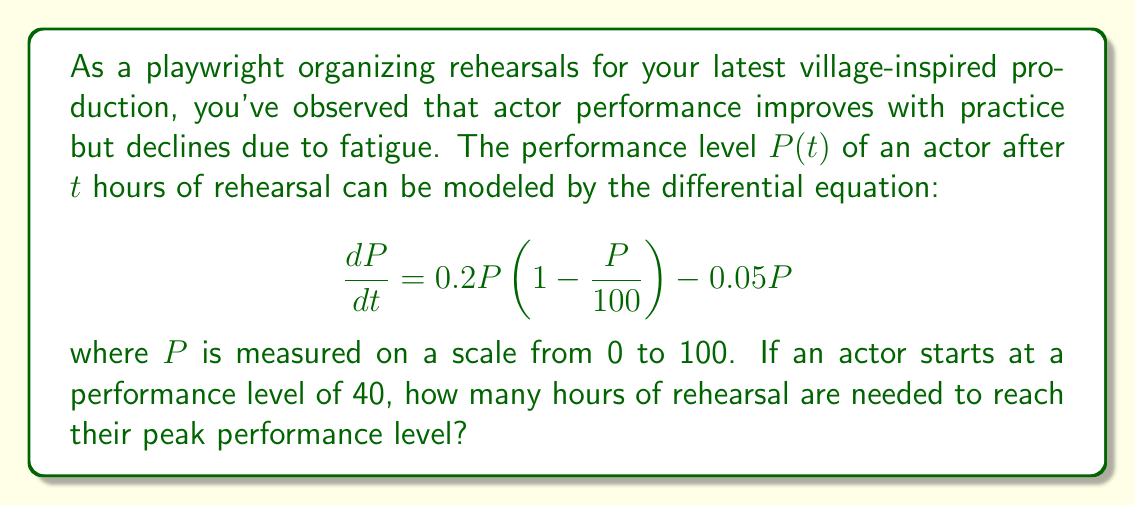Can you solve this math problem? To solve this problem, we need to follow these steps:

1) First, we need to find the equilibrium points of the differential equation. At equilibrium, $\frac{dP}{dt} = 0$. So:

   $$0 = 0.2P(1-\frac{P}{100}) - 0.05P$$

2) Simplifying:
   
   $$0 = 0.2P - 0.002P^2 - 0.05P = 0.15P - 0.002P^2$$

3) Factoring out P:
   
   $$P(0.15 - 0.002P) = 0$$

4) This equation is satisfied when $P = 0$ or when $0.15 - 0.002P = 0$. Solving the second equation:

   $$0.002P = 0.15$$
   $$P = 75$$

5) So, the non-zero equilibrium point is at $P = 75$. This represents the peak performance level.

6) To find how long it takes to reach this level, we need to solve the differential equation. This is a separable equation:

   $$\frac{dP}{0.2P(1-\frac{P}{100}) - 0.05P} = dt$$

7) This can be solved using partial fractions, but the solution is complex. Instead, we can use numerical methods like Euler's method or a Runge-Kutta method to approximate the solution.

8) Using a numerical solver (like ode45 in MATLAB or scipy.integrate.odeint in Python), we can find that it takes approximately 15.7 hours to reach 99% of the peak performance (74.25).
Answer: Approximately 15.7 hours of rehearsal are needed for an actor to reach their peak performance level. 